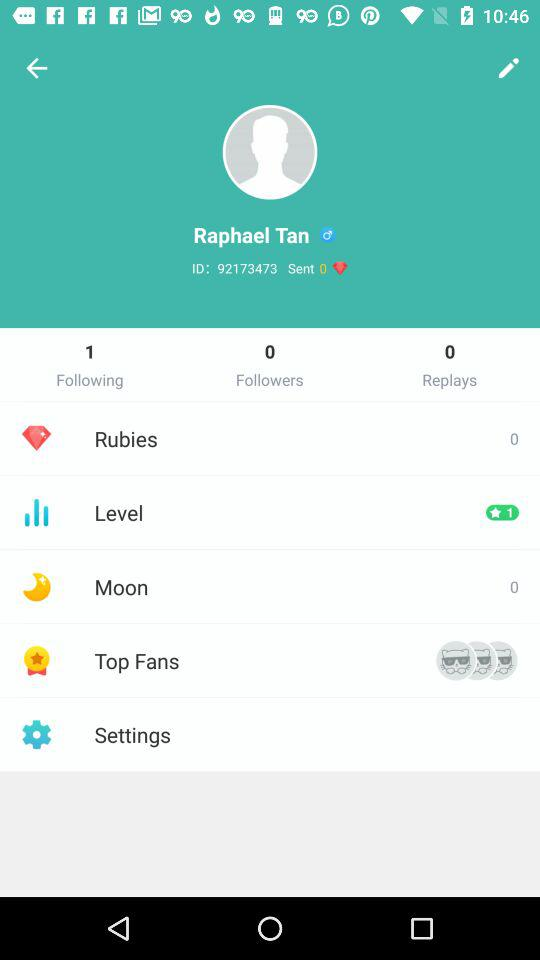How many moons are there? There are 0 moons. 